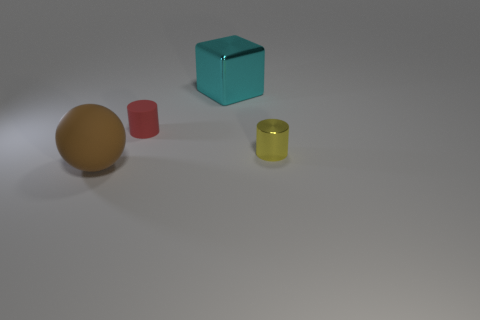How would you describe the lighting and shadows in the scene? The lighting in the image seems to be coming from above and to the right, casting gentle shadows to the left of the objects. This creates a soft and diffuse look in the scene, suggesting an indoor environment with ambient lighting, perhaps from overhead lights. The softness of the shadows indicates that the light source is not very harsh or direct. 